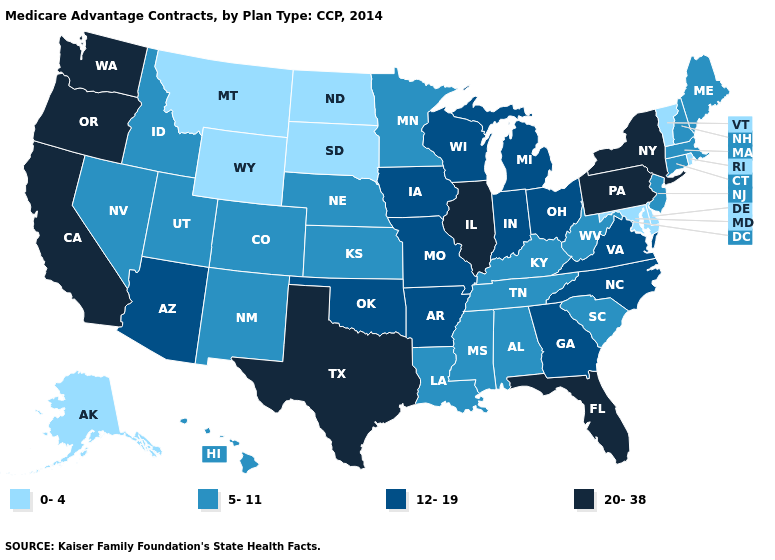Is the legend a continuous bar?
Write a very short answer. No. Which states have the lowest value in the USA?
Give a very brief answer. Alaska, Delaware, Maryland, Montana, North Dakota, Rhode Island, South Dakota, Vermont, Wyoming. How many symbols are there in the legend?
Answer briefly. 4. What is the highest value in the USA?
Short answer required. 20-38. What is the value of Nevada?
Short answer required. 5-11. What is the value of Oregon?
Keep it brief. 20-38. What is the value of New York?
Short answer required. 20-38. What is the value of Alaska?
Concise answer only. 0-4. Name the states that have a value in the range 20-38?
Concise answer only. California, Florida, Illinois, New York, Oregon, Pennsylvania, Texas, Washington. What is the highest value in states that border Arkansas?
Keep it brief. 20-38. What is the value of Oregon?
Answer briefly. 20-38. Does the first symbol in the legend represent the smallest category?
Short answer required. Yes. Does Idaho have a lower value than South Carolina?
Write a very short answer. No. Name the states that have a value in the range 0-4?
Quick response, please. Alaska, Delaware, Maryland, Montana, North Dakota, Rhode Island, South Dakota, Vermont, Wyoming. What is the highest value in the USA?
Answer briefly. 20-38. 